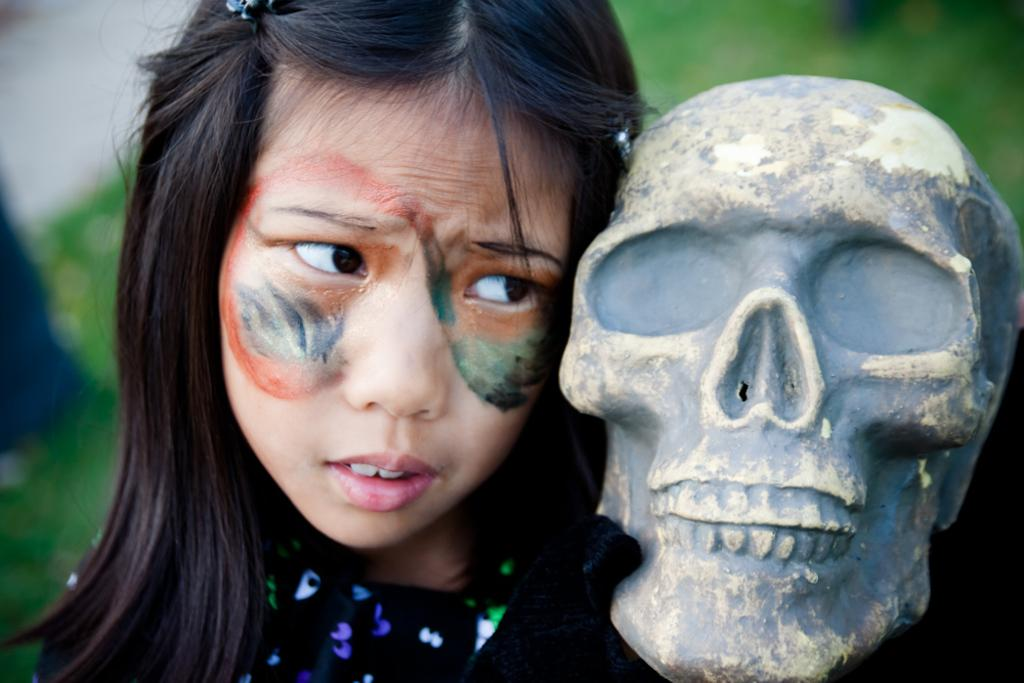Who is the main subject in the image? There is a girl in the center of the image. What is on the girl's face? There is paint on the girl's face. What object is near the girl? There is a skull near the girl. How would you describe the background of the image? The background of the image is blurred. Can you see a flock of potato plants near the ocean in the image? There is no reference to potato plants, an ocean, or a flock in the image. 